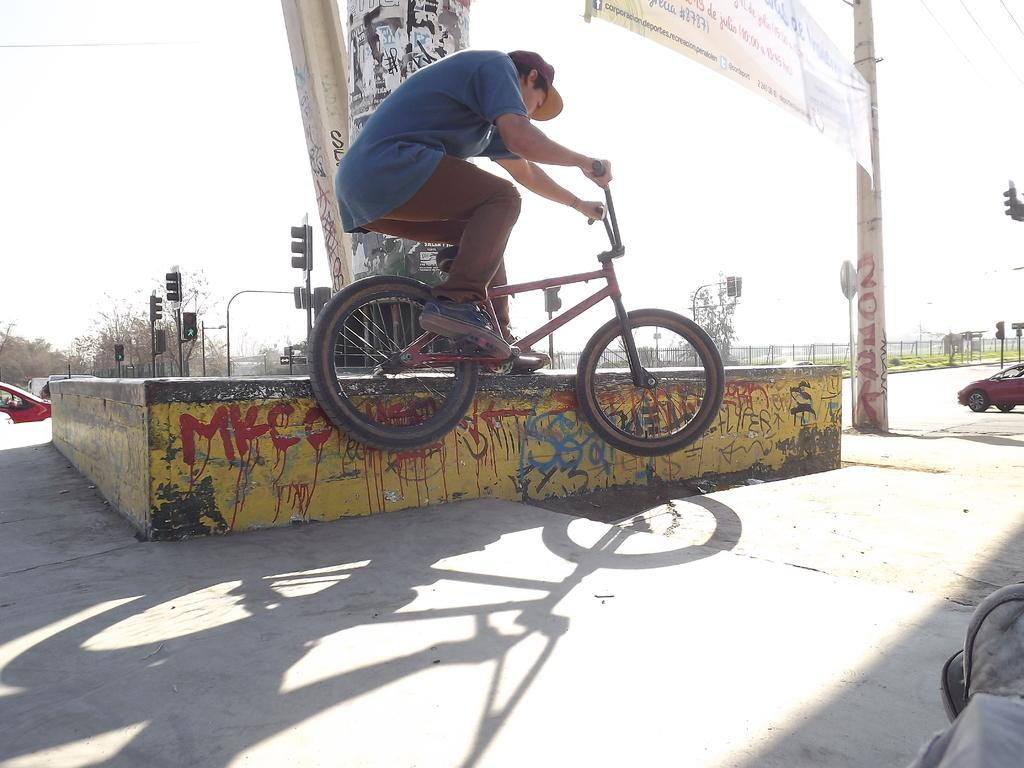What type of scene is depicted in the image? The image is an outdoor scene. What is the man in the image doing? The man is sitting on a bicycle and holding the handle of the bicycle. What can be seen attached to a pole in the image? There is a pole with a banner in the image. What is present on the road in the image? Vehicles are present on the road. What is visible in the distance in the image? Trees are visible in the distance. What safety feature is present in the image? Signal lights are present in the image. Can you see any wings on the bicycle in the image? No, there are no wings present on the bicycle in the image. What type of knife is being used to cut the banner in the image? There is no knife present in the image, nor is there any indication that the banner is being cut. 